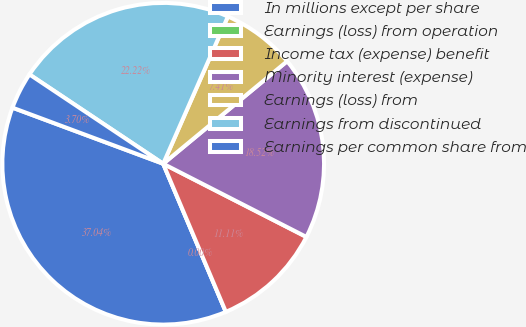Convert chart. <chart><loc_0><loc_0><loc_500><loc_500><pie_chart><fcel>In millions except per share<fcel>Earnings (loss) from operation<fcel>Income tax (expense) benefit<fcel>Minority interest (expense)<fcel>Earnings (loss) from<fcel>Earnings from discontinued<fcel>Earnings per common share from<nl><fcel>37.04%<fcel>0.0%<fcel>11.11%<fcel>18.52%<fcel>7.41%<fcel>22.22%<fcel>3.7%<nl></chart> 